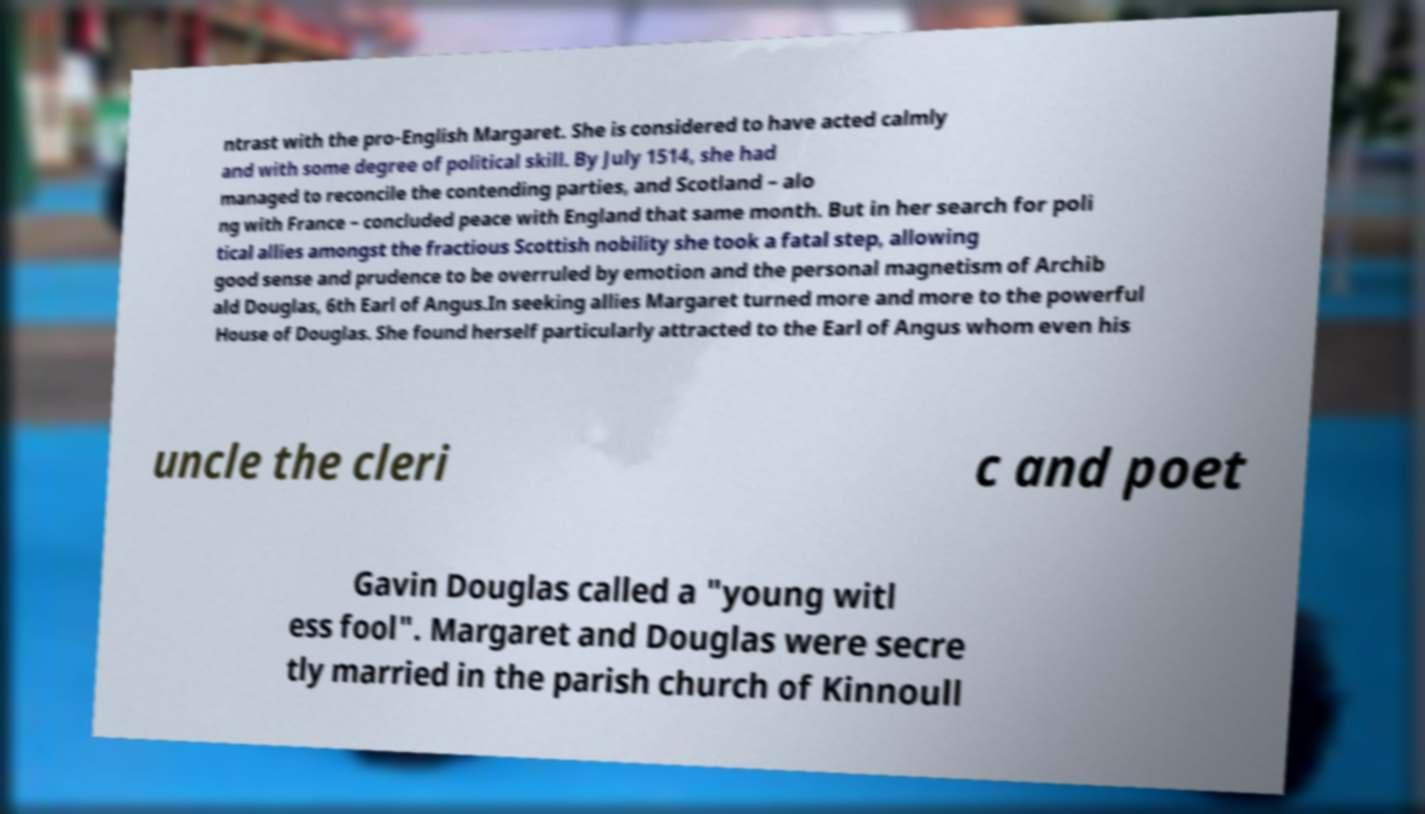I need the written content from this picture converted into text. Can you do that? ntrast with the pro-English Margaret. She is considered to have acted calmly and with some degree of political skill. By July 1514, she had managed to reconcile the contending parties, and Scotland – alo ng with France – concluded peace with England that same month. But in her search for poli tical allies amongst the fractious Scottish nobility she took a fatal step, allowing good sense and prudence to be overruled by emotion and the personal magnetism of Archib ald Douglas, 6th Earl of Angus.In seeking allies Margaret turned more and more to the powerful House of Douglas. She found herself particularly attracted to the Earl of Angus whom even his uncle the cleri c and poet Gavin Douglas called a "young witl ess fool". Margaret and Douglas were secre tly married in the parish church of Kinnoull 